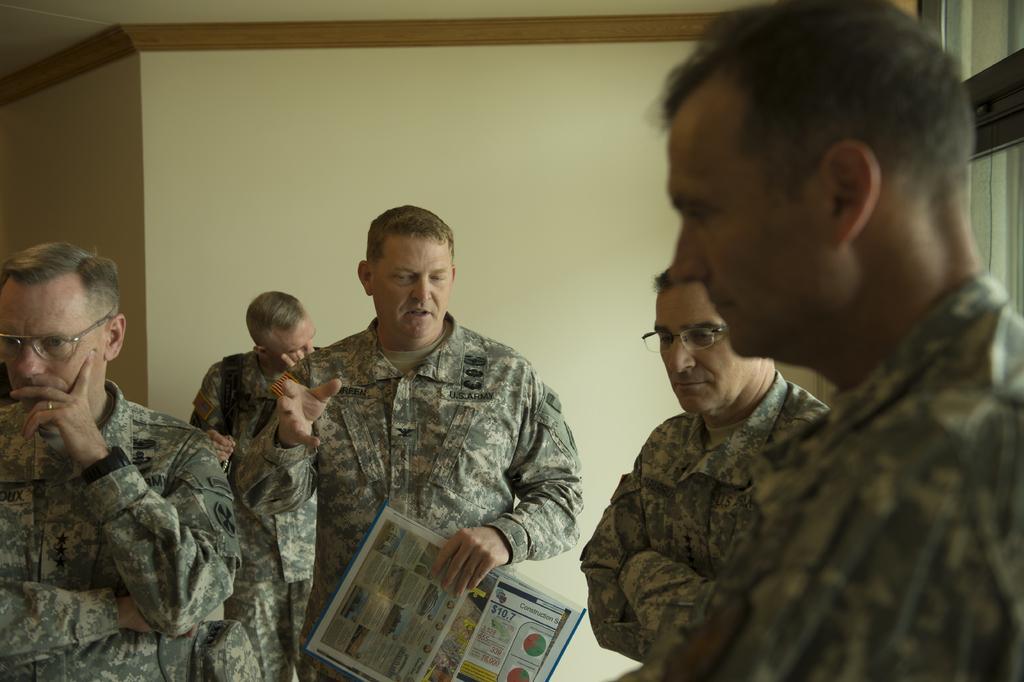Please provide a concise description of this image. In this image I can see in the middle a man is speaking. Around him there are few men all of them are wearing the army dresses. 